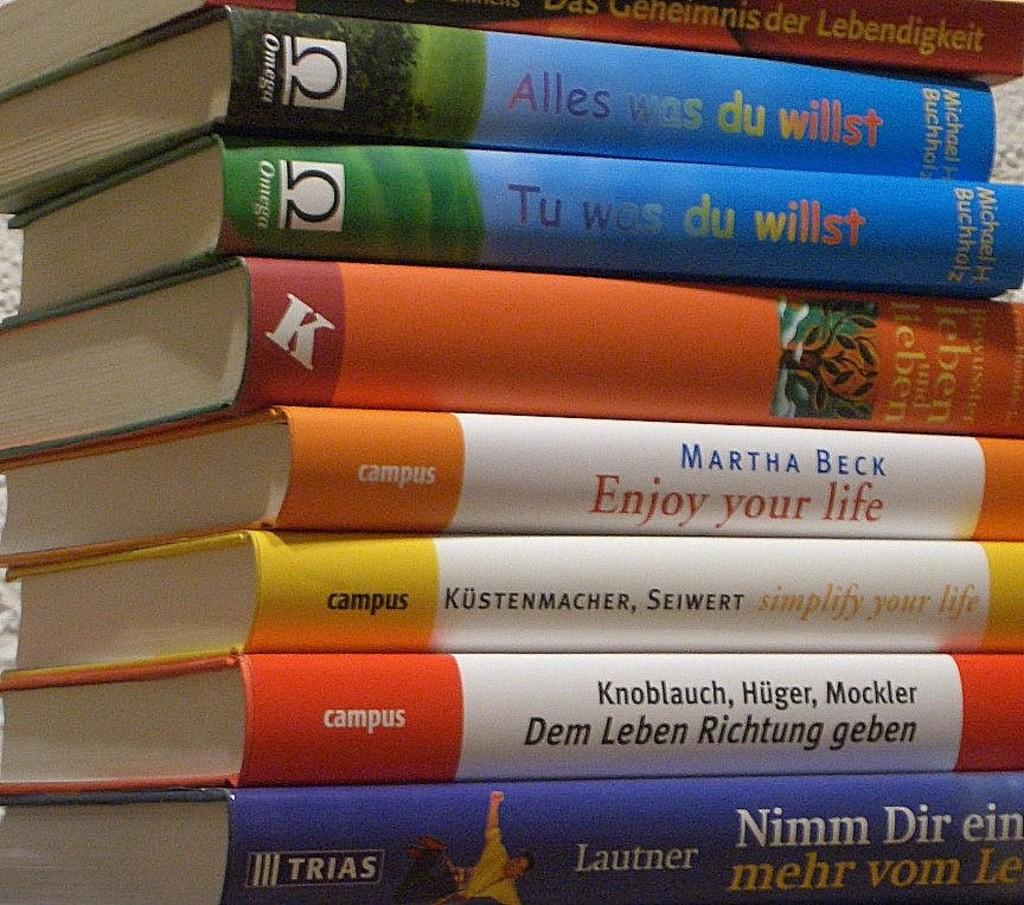<image>
Relay a brief, clear account of the picture shown. A stack of books includes one by Martha Beck. 